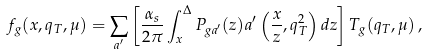Convert formula to latex. <formula><loc_0><loc_0><loc_500><loc_500>f _ { g } ( x , q _ { T } , \mu ) = \sum _ { a ^ { \prime } } \left [ \frac { \alpha _ { s } } { 2 \pi } \int ^ { \Delta } _ { x } P _ { g a ^ { \prime } } ( z ) a ^ { \prime } \left ( \frac { x } { z } , q _ { T } ^ { 2 } \right ) d z \right ] T _ { g } ( q _ { T } , \mu ) \, ,</formula> 